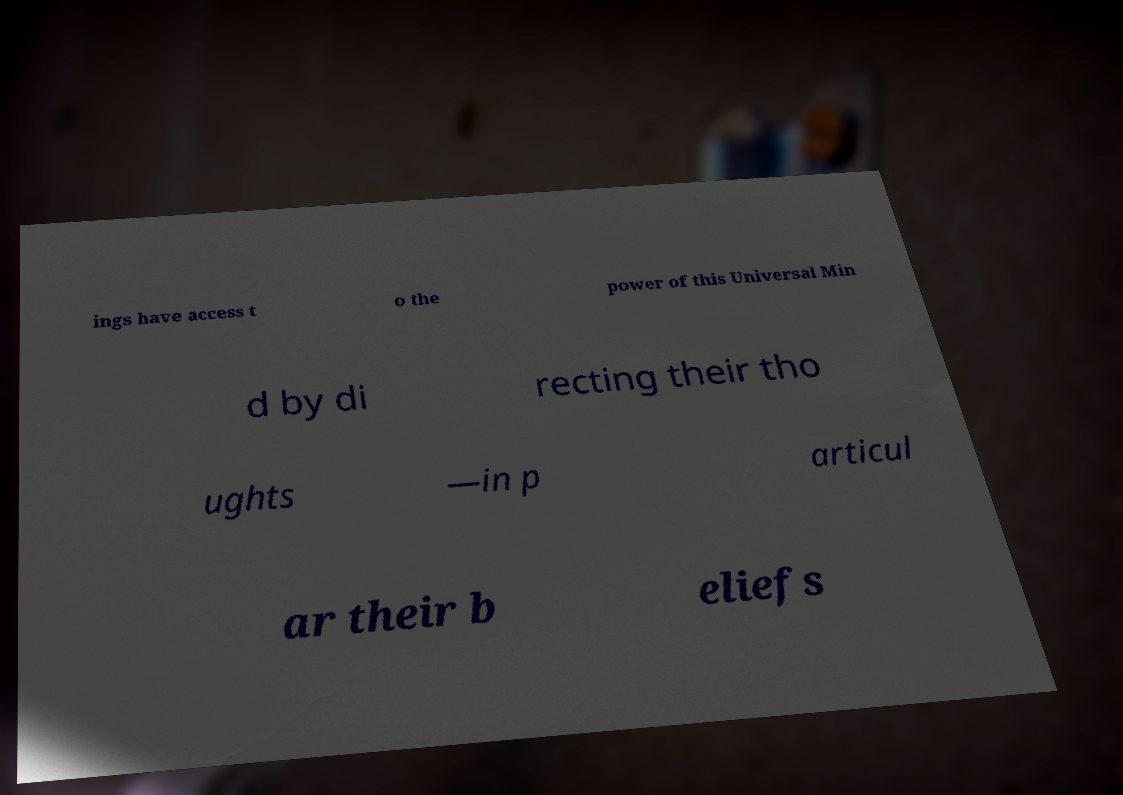Could you extract and type out the text from this image? ings have access t o the power of this Universal Min d by di recting their tho ughts —in p articul ar their b eliefs 